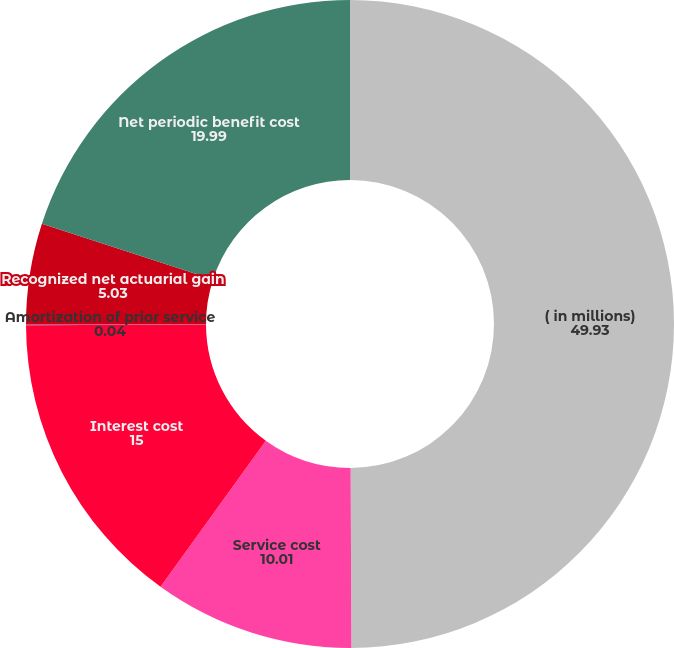<chart> <loc_0><loc_0><loc_500><loc_500><pie_chart><fcel>( in millions)<fcel>Service cost<fcel>Interest cost<fcel>Amortization of prior service<fcel>Recognized net actuarial gain<fcel>Net periodic benefit cost<nl><fcel>49.93%<fcel>10.01%<fcel>15.0%<fcel>0.04%<fcel>5.03%<fcel>19.99%<nl></chart> 